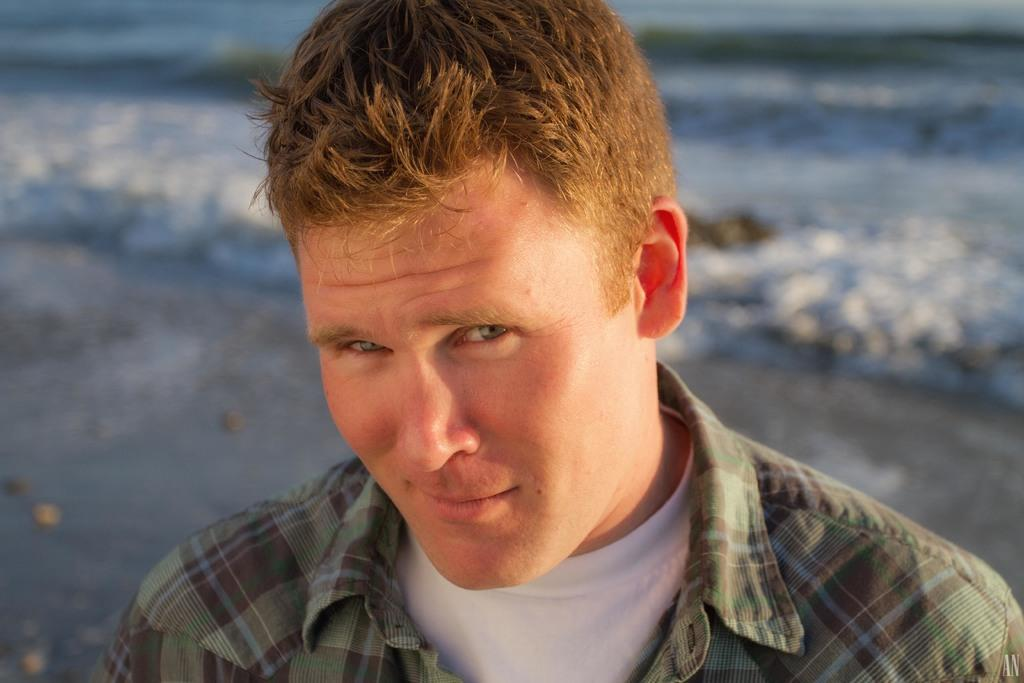What is the main subject of the image? There is a man in the image. What type of wool can be seen coming out of the volcano in the image? There is no volcano or wool present in the image; it features a man. How many cherries can be seen on the man's head in the image? There are no cherries present on the man's head in the image. 